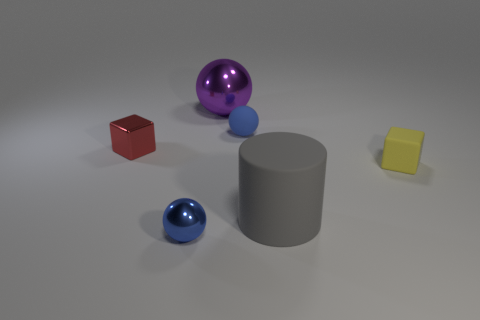Add 2 shiny objects. How many objects exist? 8 Subtract all cylinders. How many objects are left? 5 Add 6 gray cylinders. How many gray cylinders exist? 7 Subtract 0 red cylinders. How many objects are left? 6 Subtract all tiny purple rubber cubes. Subtract all tiny blue spheres. How many objects are left? 4 Add 3 tiny matte spheres. How many tiny matte spheres are left? 4 